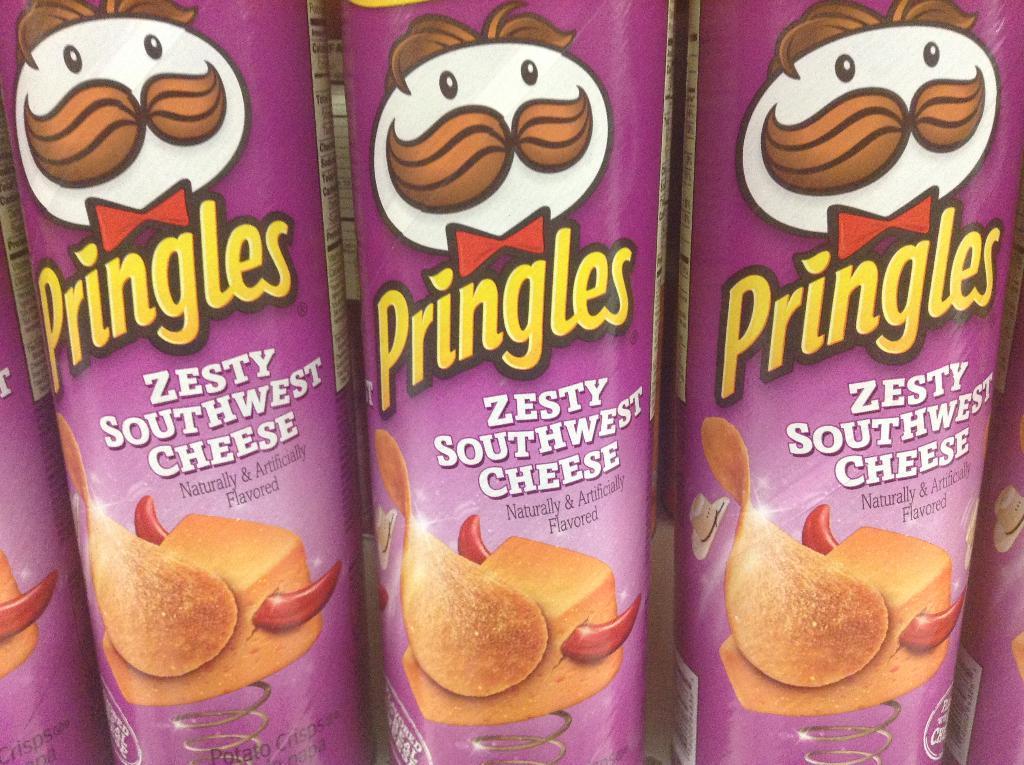Describe this image in one or two sentences. In this picture we can see boxes and on this boxes we can see bow ties, caps and springs. 